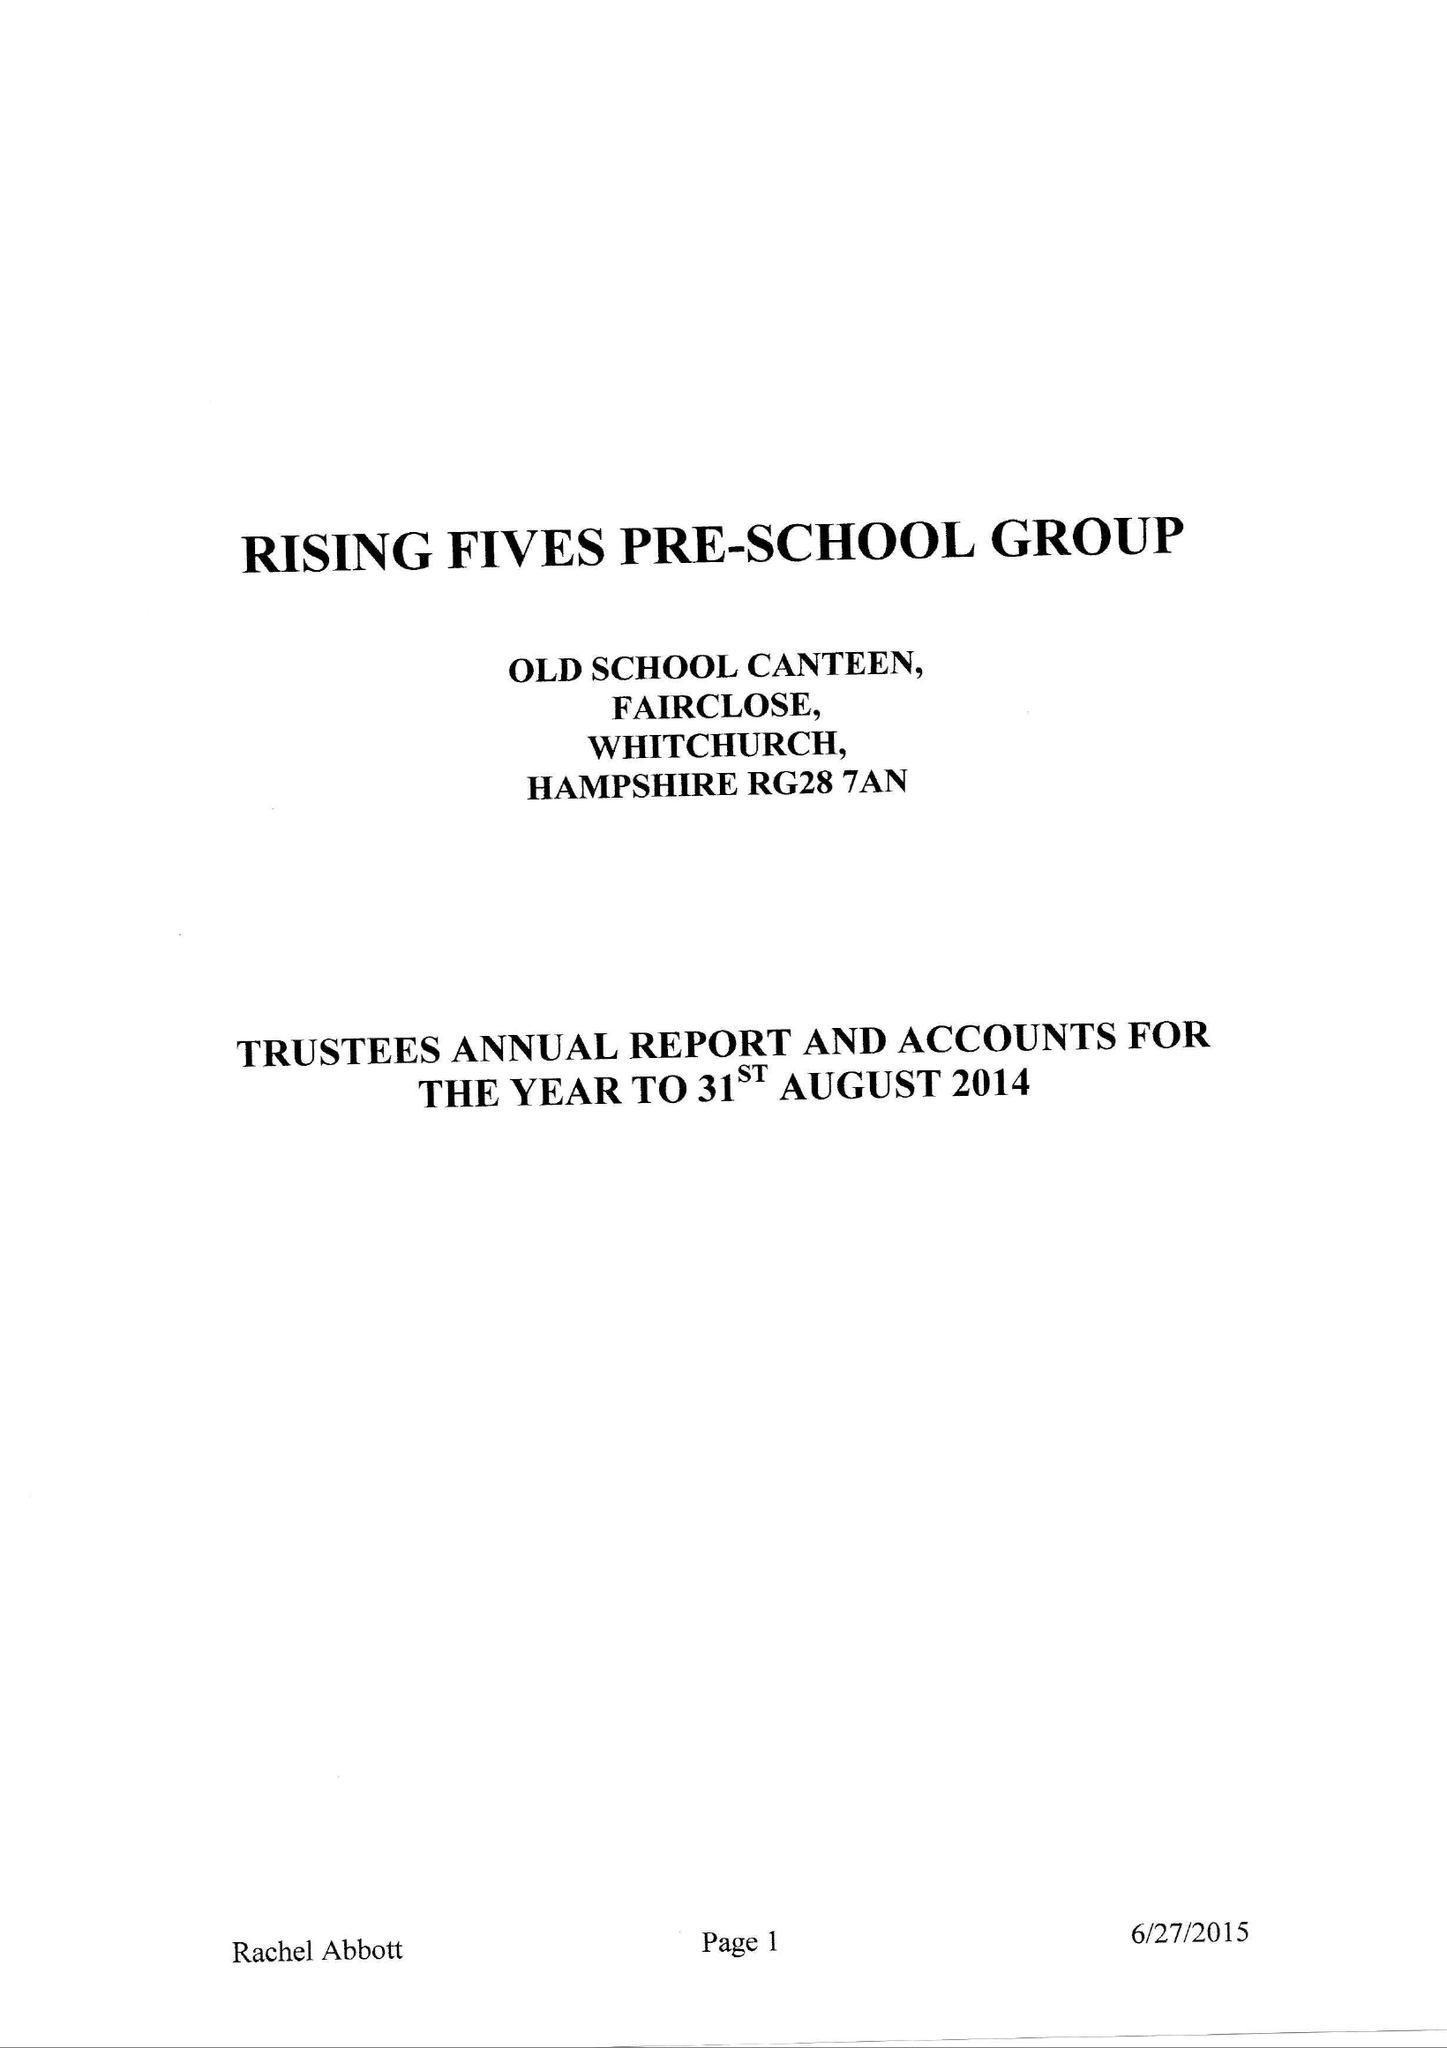What is the value for the address__postcode?
Answer the question using a single word or phrase. RG28 7AN 